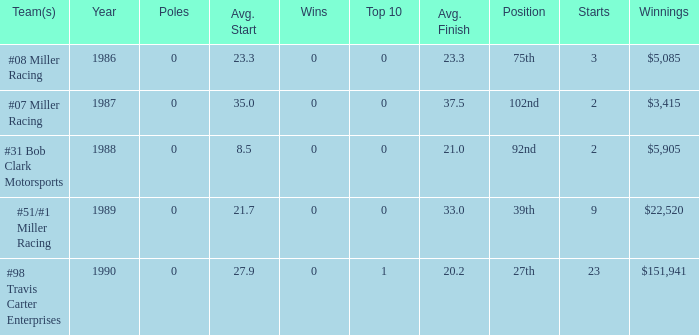What are the racing teams for which the average finish is 23.3? #08 Miller Racing. 